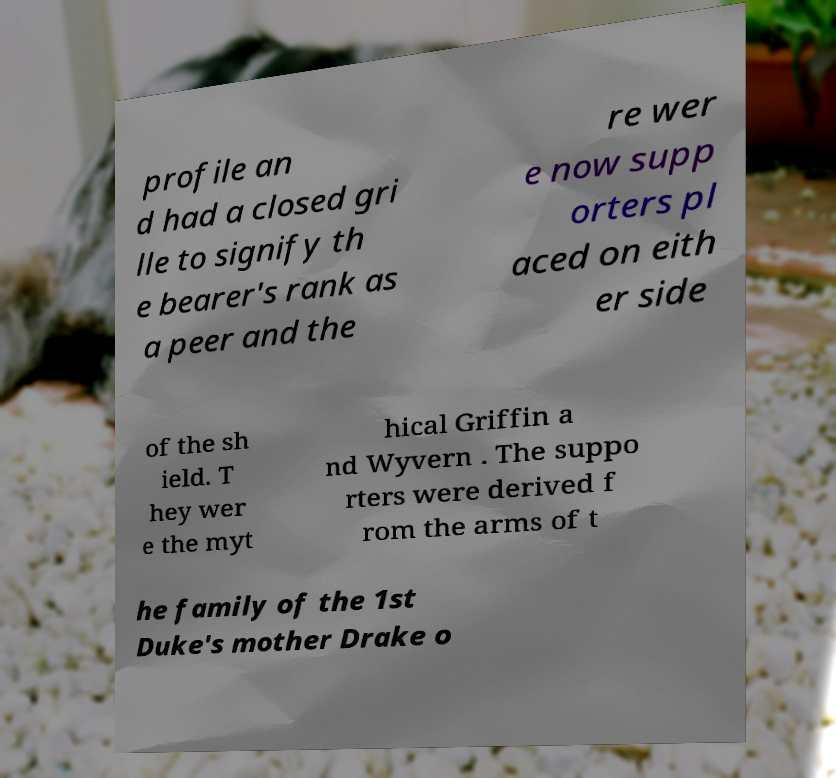Please identify and transcribe the text found in this image. profile an d had a closed gri lle to signify th e bearer's rank as a peer and the re wer e now supp orters pl aced on eith er side of the sh ield. T hey wer e the myt hical Griffin a nd Wyvern . The suppo rters were derived f rom the arms of t he family of the 1st Duke's mother Drake o 